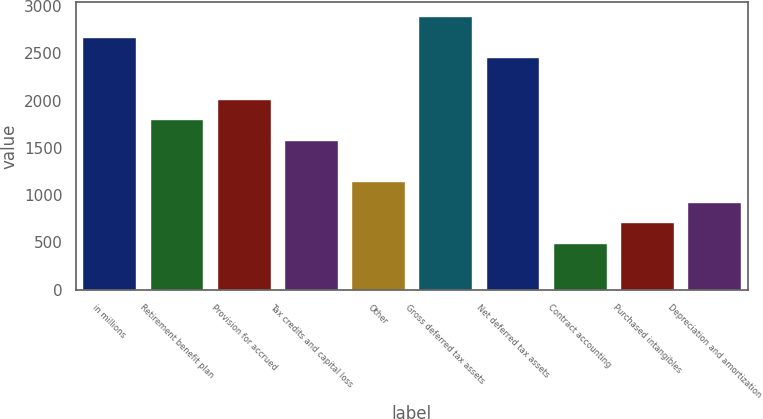<chart> <loc_0><loc_0><loc_500><loc_500><bar_chart><fcel>in millions<fcel>Retirement benefit plan<fcel>Provision for accrued<fcel>Tax credits and capital loss<fcel>Other<fcel>Gross deferred tax assets<fcel>Net deferred tax assets<fcel>Contract accounting<fcel>Purchased intangibles<fcel>Depreciation and amortization<nl><fcel>2678.7<fcel>1803.9<fcel>2022.6<fcel>1585.2<fcel>1147.8<fcel>2897.4<fcel>2460<fcel>491.7<fcel>710.4<fcel>929.1<nl></chart> 